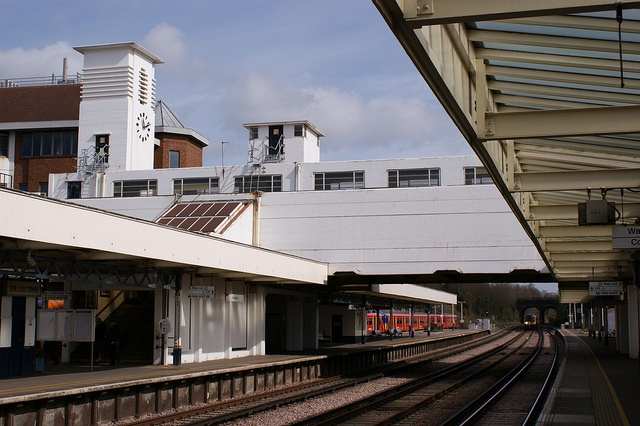Describe the objects in this image and their specific colors. I can see train in gray, black, brown, and maroon tones, clock in gray, white, darkgray, and black tones, and train in gray, black, maroon, and brown tones in this image. 